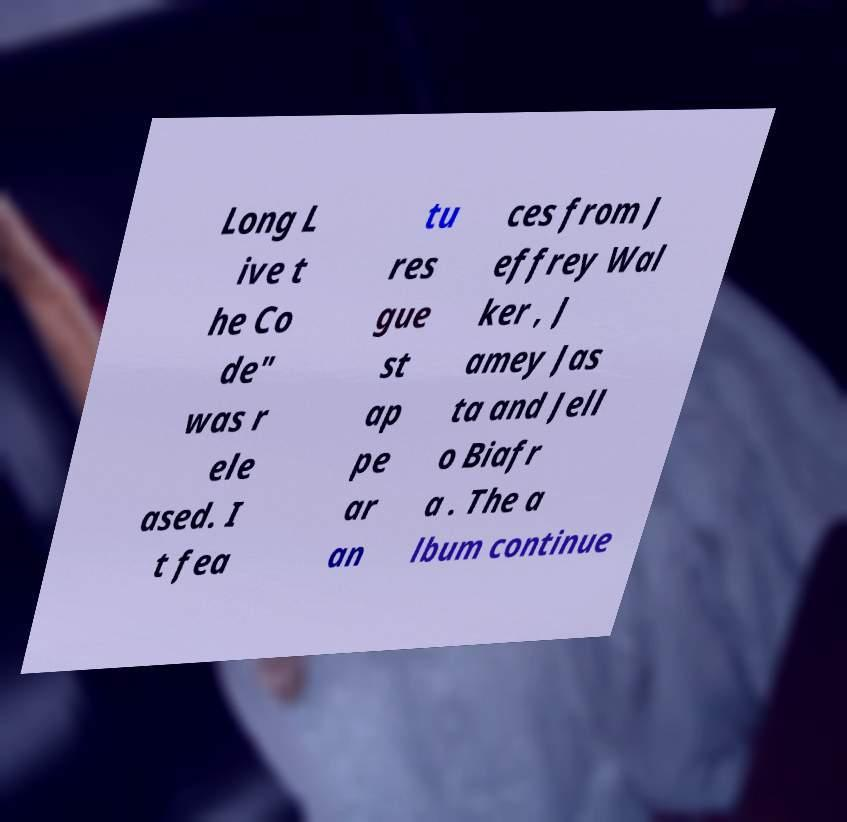Could you assist in decoding the text presented in this image and type it out clearly? Long L ive t he Co de" was r ele ased. I t fea tu res gue st ap pe ar an ces from J effrey Wal ker , J amey Jas ta and Jell o Biafr a . The a lbum continue 